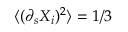<formula> <loc_0><loc_0><loc_500><loc_500>\langle ( \partial _ { s } X _ { i } ) ^ { 2 } \rangle = 1 / 3</formula> 